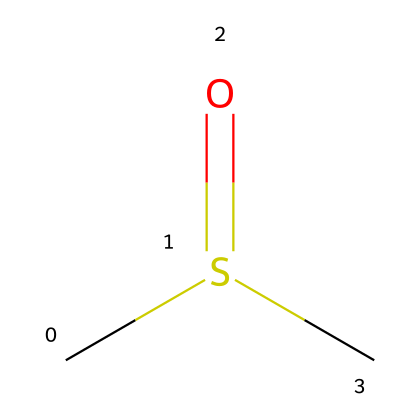What is the molecular formula of this compound? The SMILES representation indicates there are two carbon (C) atoms, one sulfur (S) atom, and one oxygen (O) atom. Therefore, the molecular formula can be derived as C2H6OS.
Answer: C2H6OS How many hydrogen atoms are present in dimethyl sulfoxide? By analyzing the SMILES representation, we can see it contains six hydrogen atoms attached to two carbon atoms and one sulfur atom.
Answer: six What type of chemical bonding is present in DMSO? The chemical structure shows a double bond between the sulfur and oxygen atoms (C=S) and single bonds between carbon and the other groups. This indicates the presence of covalent bonding.
Answer: covalent Does this compound contain a functional group? Yes, the presence of the sulfoxide functional group (R-S(=O)-R') is indicated by the sulfur and its double-bonded oxygen.
Answer: yes How many total atoms are there in the dimethyl sulfoxide molecule? The total atom count includes two carbon, one sulfur, one oxygen, and six hydrogen atoms, giving a total of ten atoms.
Answer: ten What makes dimethyl sulfoxide a polar solvent? The presence of a sulfur-oxygen double bond (S=O) alongside the polar C-S bonds leads to uneven distribution of charge, making the molecule polar.
Answer: polar What is the primary use of dimethyl sulfoxide in medicine? Dimethyl sulfoxide is primarily used as a solvent for pharmaceuticals and as a vehicle for topical administration of certain medications.
Answer: solvent 